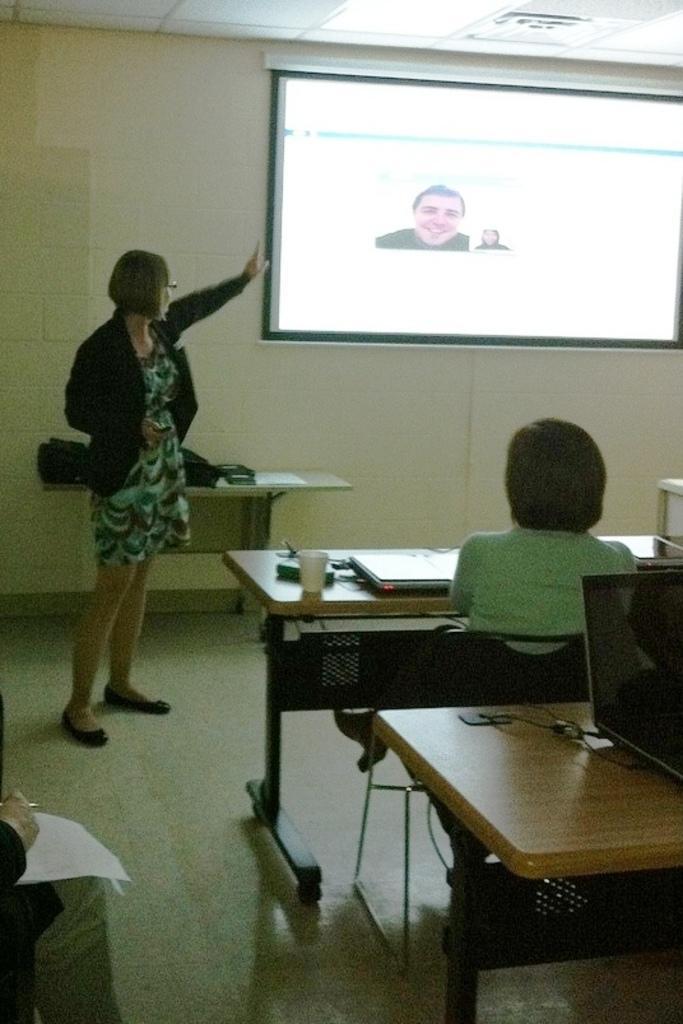How would you summarize this image in a sentence or two? In this picture we can see a woman wore blazer, spectacle showing on screen and in front of her we can see woman and a person sitting on chair and in front of them there is table and on table we have glass, book, laptop, papers and this screen is to the wall. 